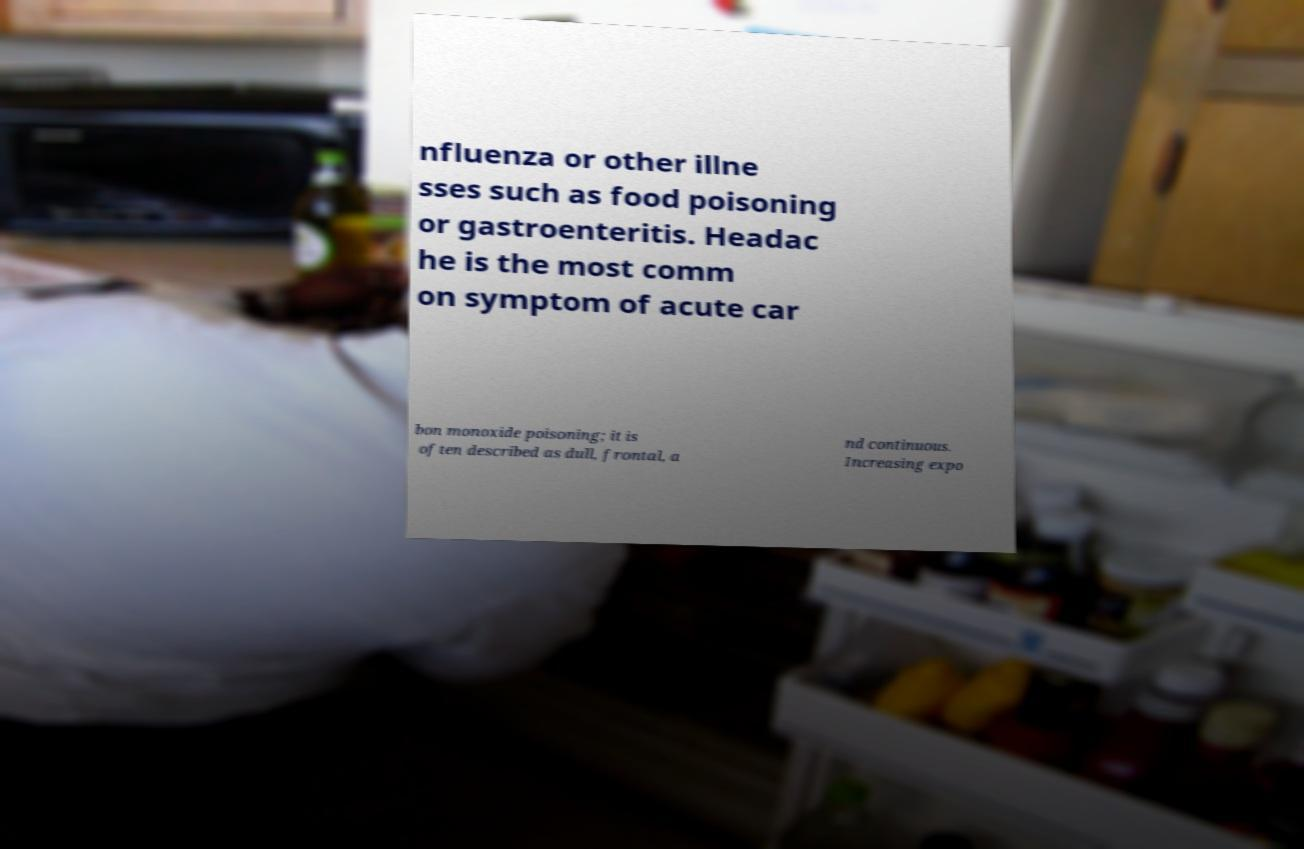I need the written content from this picture converted into text. Can you do that? nfluenza or other illne sses such as food poisoning or gastroenteritis. Headac he is the most comm on symptom of acute car bon monoxide poisoning; it is often described as dull, frontal, a nd continuous. Increasing expo 